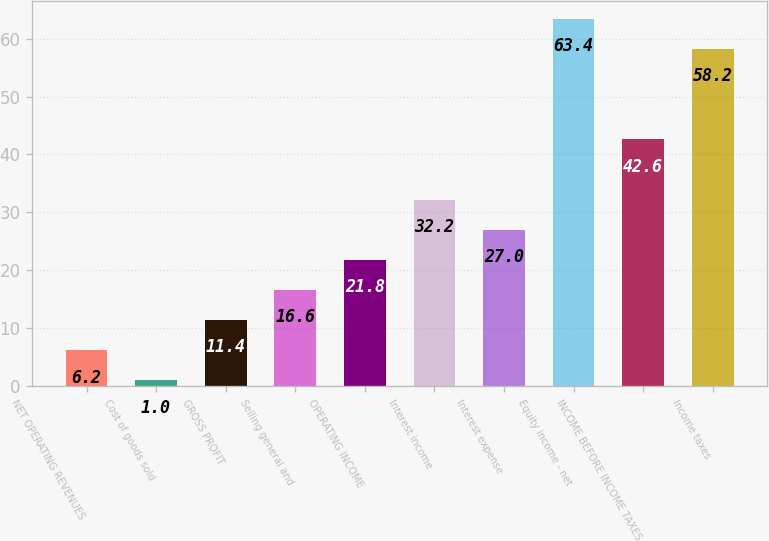Convert chart. <chart><loc_0><loc_0><loc_500><loc_500><bar_chart><fcel>NET OPERATING REVENUES<fcel>Cost of goods sold<fcel>GROSS PROFIT<fcel>Selling general and<fcel>OPERATING INCOME<fcel>Interest income<fcel>Interest expense<fcel>Equity income - net<fcel>INCOME BEFORE INCOME TAXES<fcel>Income taxes<nl><fcel>6.2<fcel>1<fcel>11.4<fcel>16.6<fcel>21.8<fcel>32.2<fcel>27<fcel>63.4<fcel>42.6<fcel>58.2<nl></chart> 